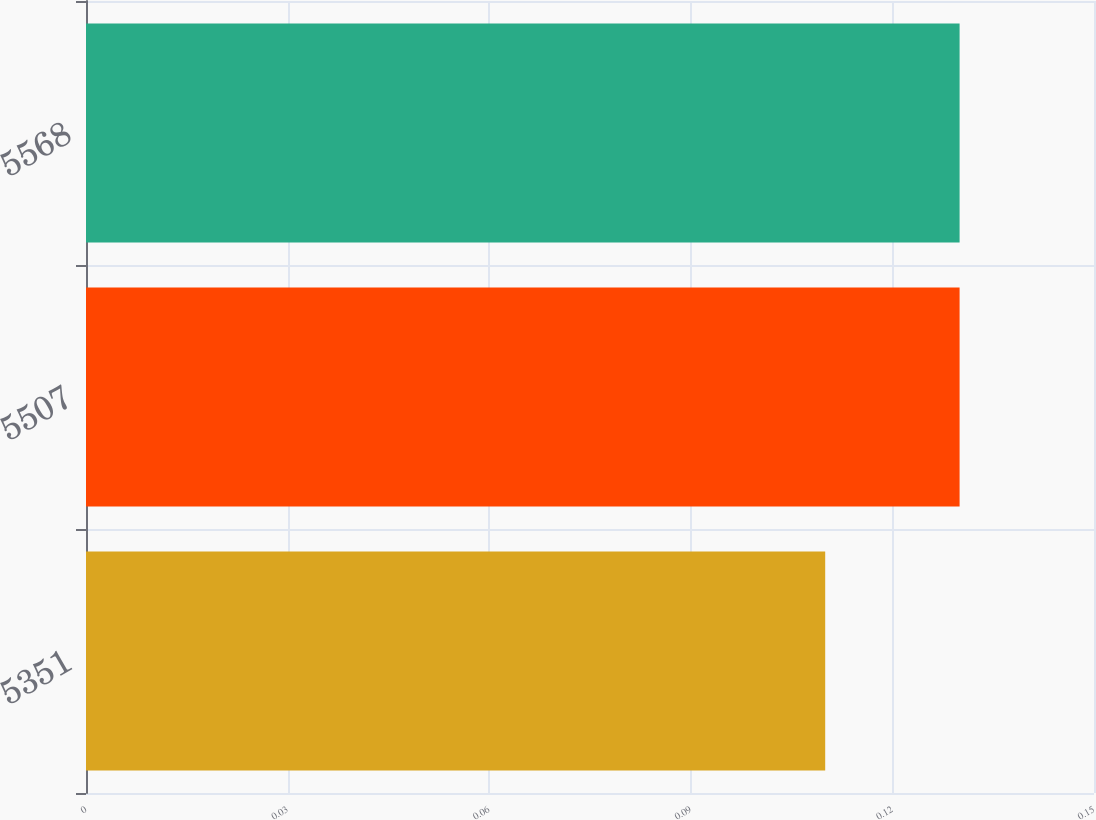Convert chart. <chart><loc_0><loc_0><loc_500><loc_500><bar_chart><fcel>5351<fcel>5507<fcel>5568<nl><fcel>0.11<fcel>0.13<fcel>0.13<nl></chart> 